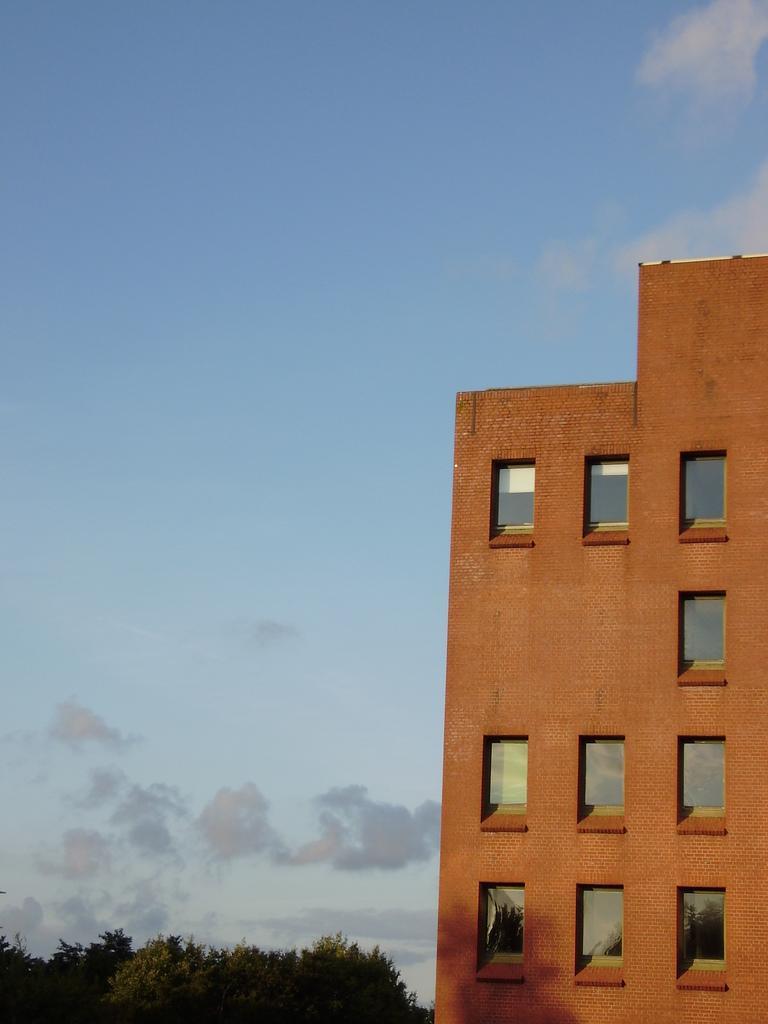Could you give a brief overview of what you see in this image? In this image there is the sky truncated, there are clouds in the sky, there is a building truncated towards the right of the image, there are windows, there are trees truncated towards the bottom of the image. 